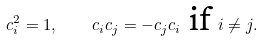Convert formula to latex. <formula><loc_0><loc_0><loc_500><loc_500>c _ { i } ^ { 2 } = 1 , \quad c _ { i } c _ { j } = - c _ { j } c _ { i } \text { if } i \neq j .</formula> 